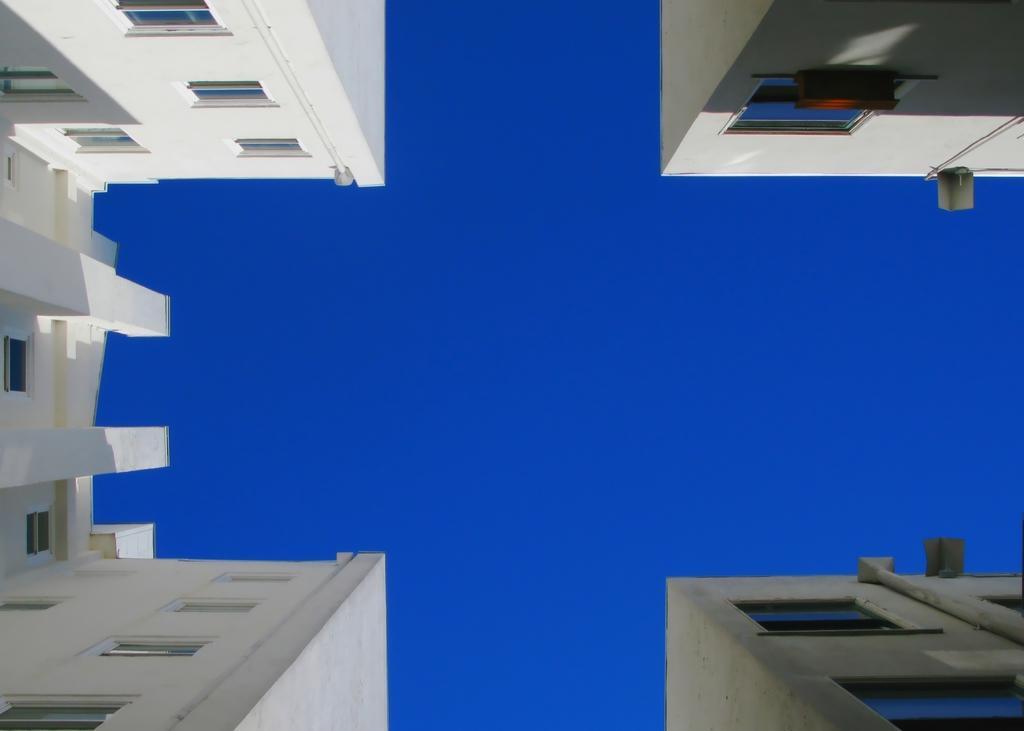Could you give a brief overview of what you see in this image? In this image, there is a ground view of buildings. There is a sky in the middle of the image. 